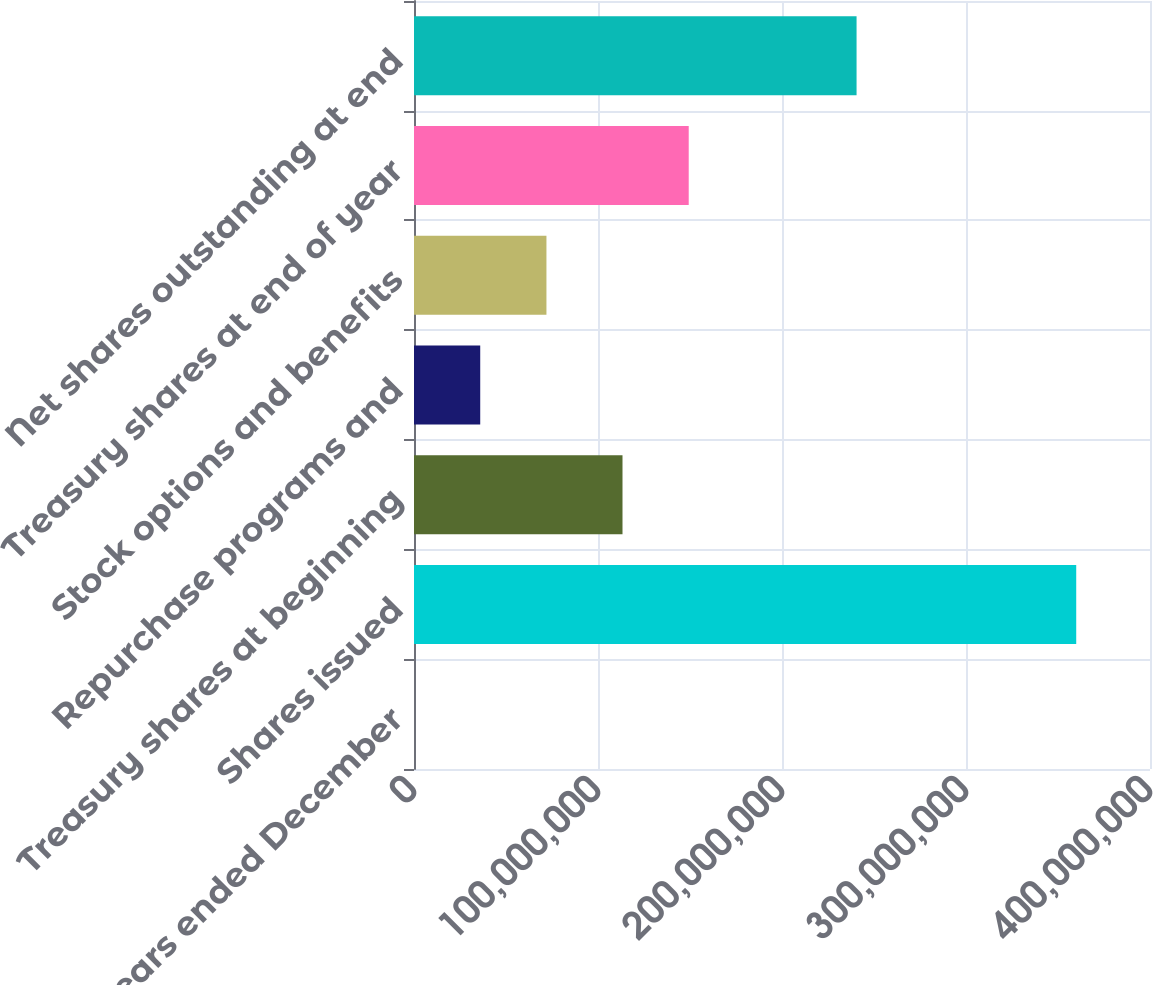Convert chart to OTSL. <chart><loc_0><loc_0><loc_500><loc_500><bar_chart><fcel>For the years ended December<fcel>Shares issued<fcel>Treasury shares at beginning<fcel>Repurchase programs and<fcel>Stock options and benefits<fcel>Treasury shares at end of year<fcel>Net shares outstanding at end<nl><fcel>2005<fcel>3.59902e+08<fcel>1.13314e+08<fcel>3.5992e+07<fcel>7.1982e+07<fcel>1.49304e+08<fcel>2.40524e+08<nl></chart> 